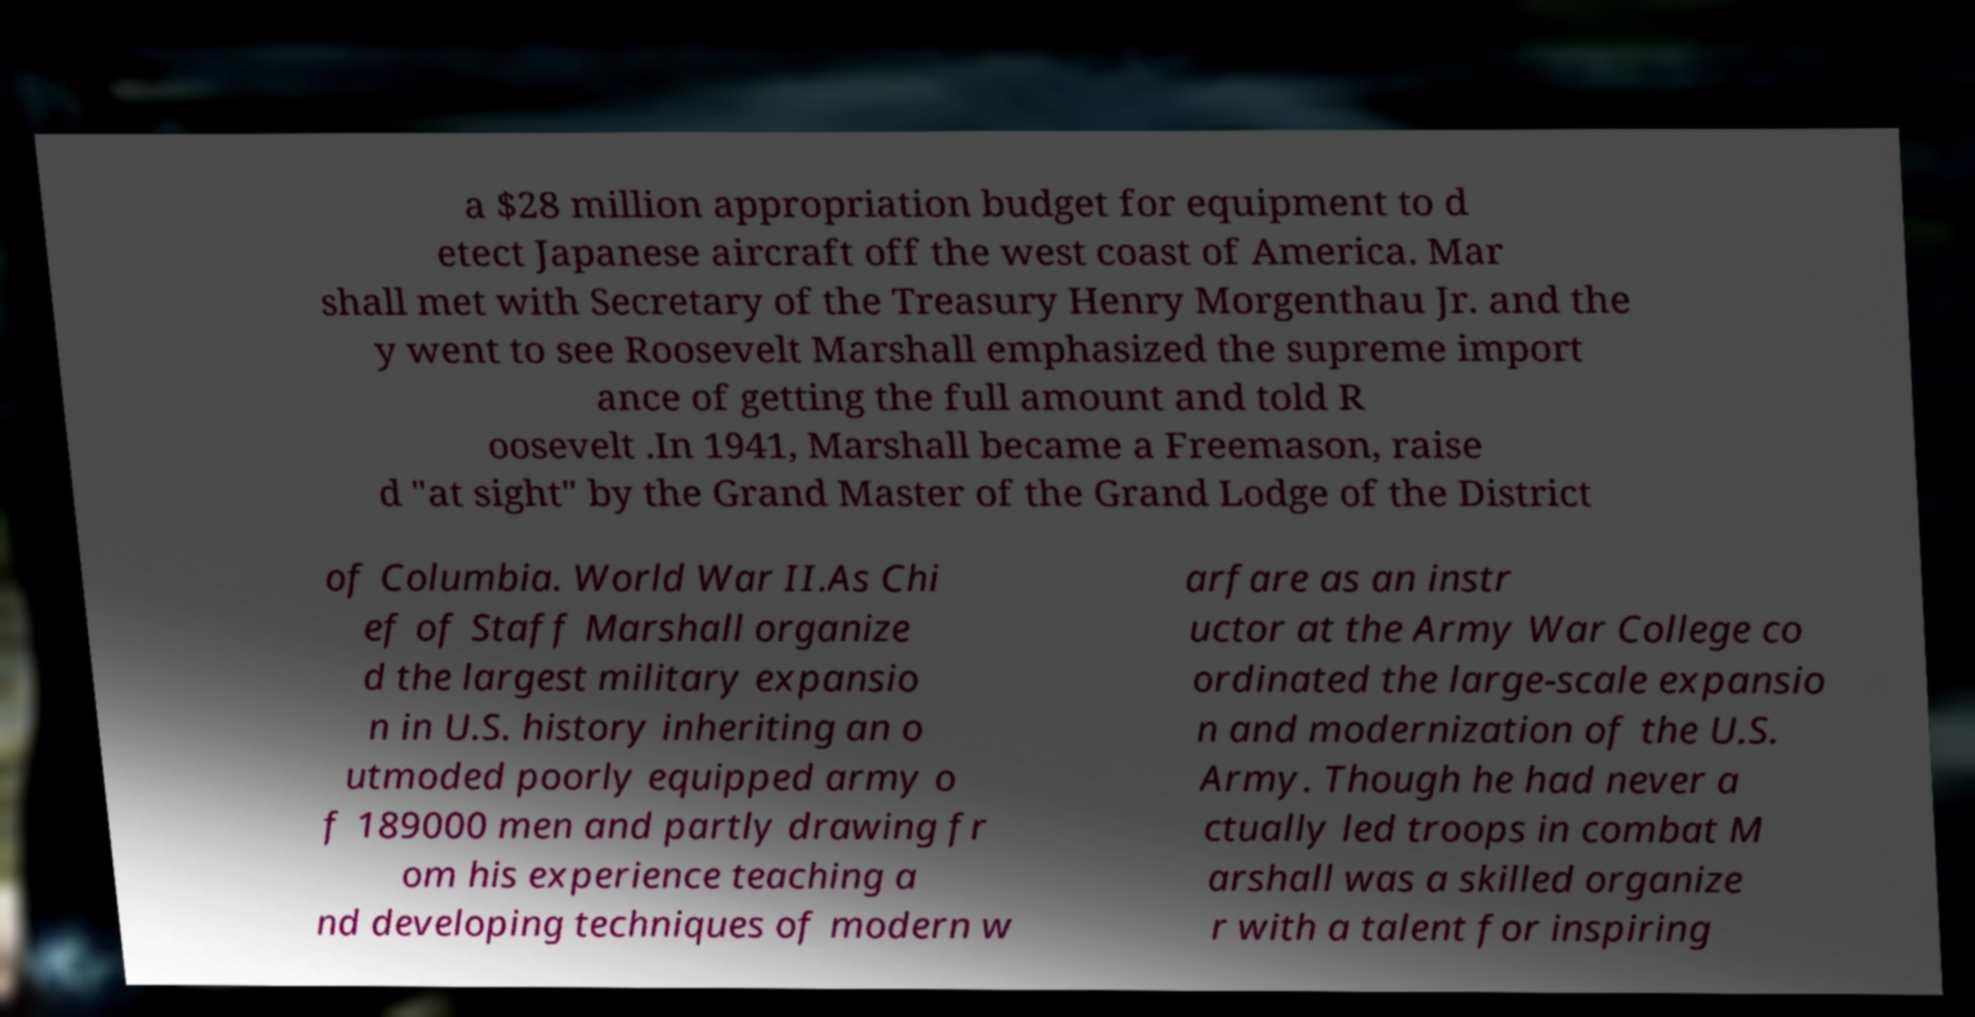I need the written content from this picture converted into text. Can you do that? a $28 million appropriation budget for equipment to d etect Japanese aircraft off the west coast of America. Mar shall met with Secretary of the Treasury Henry Morgenthau Jr. and the y went to see Roosevelt Marshall emphasized the supreme import ance of getting the full amount and told R oosevelt .In 1941, Marshall became a Freemason, raise d "at sight" by the Grand Master of the Grand Lodge of the District of Columbia. World War II.As Chi ef of Staff Marshall organize d the largest military expansio n in U.S. history inheriting an o utmoded poorly equipped army o f 189000 men and partly drawing fr om his experience teaching a nd developing techniques of modern w arfare as an instr uctor at the Army War College co ordinated the large-scale expansio n and modernization of the U.S. Army. Though he had never a ctually led troops in combat M arshall was a skilled organize r with a talent for inspiring 